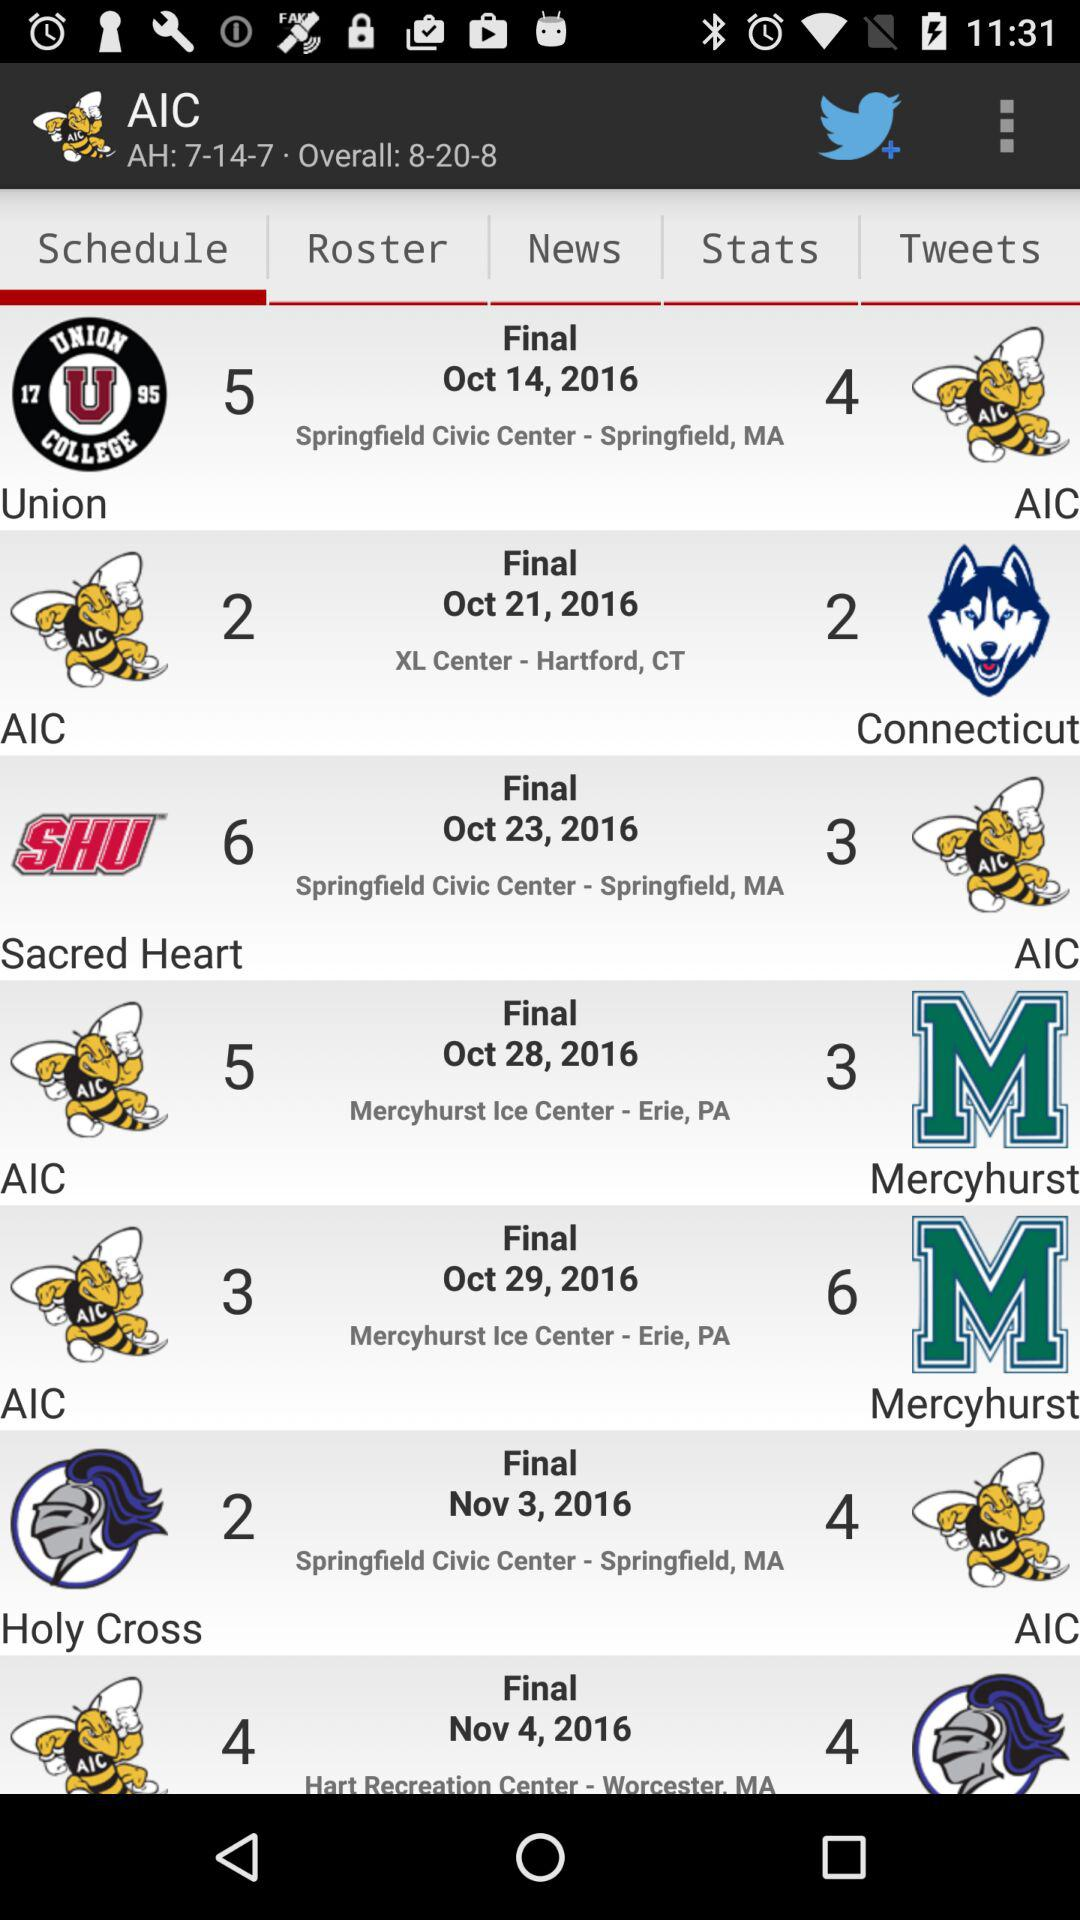What's the location of the final between "Sacred Heart" and AIC? The location of the final between "Sacred Heart" and AIC is at "Springfield Civic Center" in Springfield, MA. 